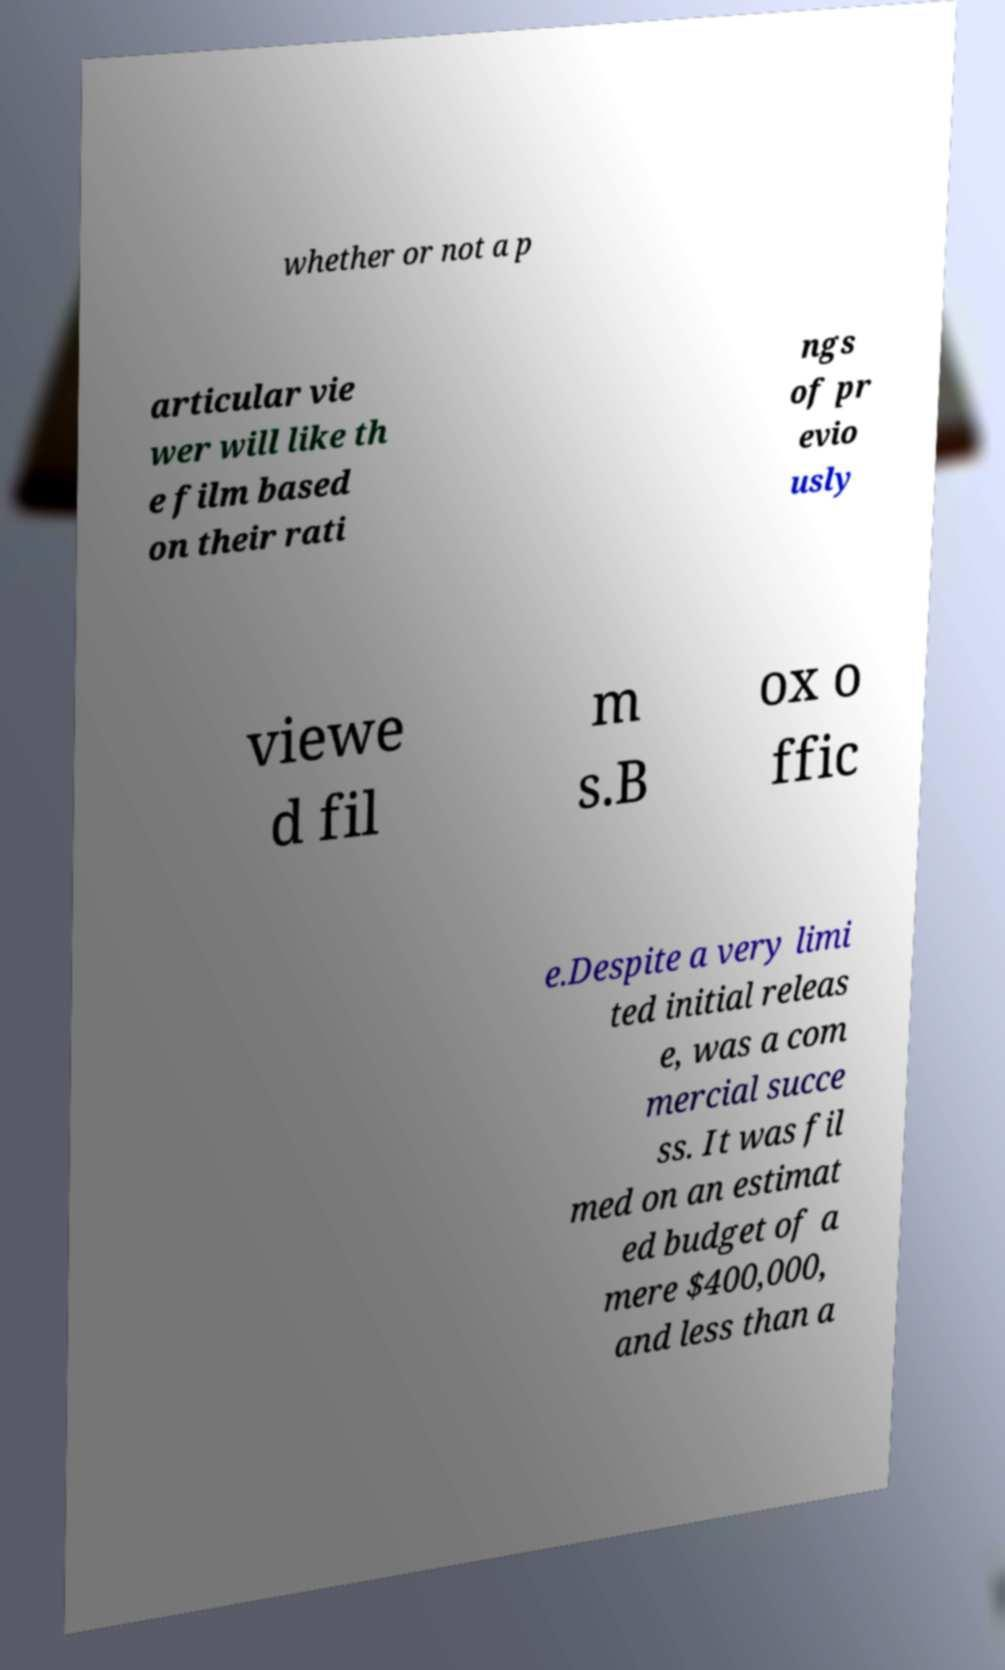Could you assist in decoding the text presented in this image and type it out clearly? whether or not a p articular vie wer will like th e film based on their rati ngs of pr evio usly viewe d fil m s.B ox o ffic e.Despite a very limi ted initial releas e, was a com mercial succe ss. It was fil med on an estimat ed budget of a mere $400,000, and less than a 